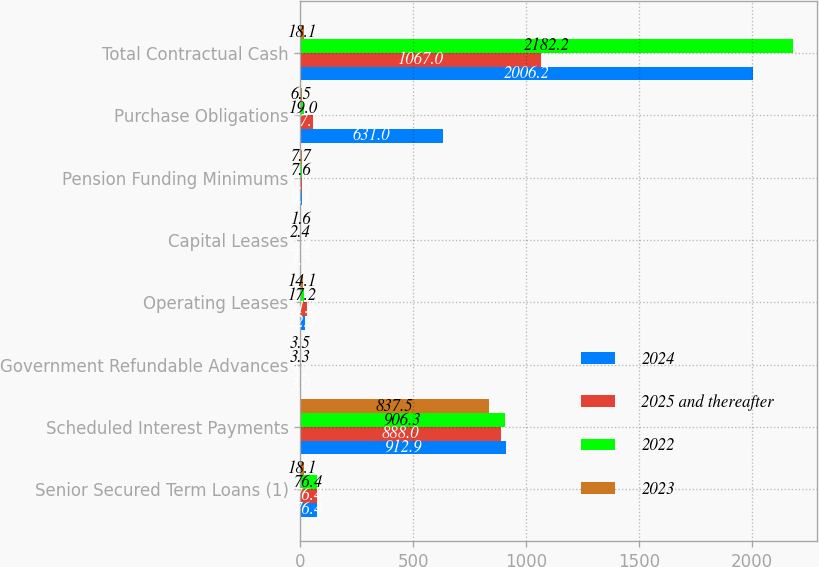Convert chart. <chart><loc_0><loc_0><loc_500><loc_500><stacked_bar_chart><ecel><fcel>Senior Secured Term Loans (1)<fcel>Scheduled Interest Payments<fcel>Government Refundable Advances<fcel>Operating Leases<fcel>Capital Leases<fcel>Pension Funding Minimums<fcel>Purchase Obligations<fcel>Total Contractual Cash<nl><fcel>2024<fcel>76.4<fcel>912.9<fcel>3<fcel>22.3<fcel>1.5<fcel>9.1<fcel>631<fcel>2006.2<nl><fcel>2025 and thereafter<fcel>76.4<fcel>888<fcel>3.2<fcel>31.5<fcel>2.4<fcel>7.8<fcel>57.7<fcel>1067<nl><fcel>2022<fcel>76.4<fcel>906.3<fcel>3.3<fcel>17.2<fcel>2.4<fcel>7.6<fcel>19<fcel>2182.2<nl><fcel>2023<fcel>18.1<fcel>837.5<fcel>3.5<fcel>14.1<fcel>1.6<fcel>7.7<fcel>6.5<fcel>18.1<nl></chart> 